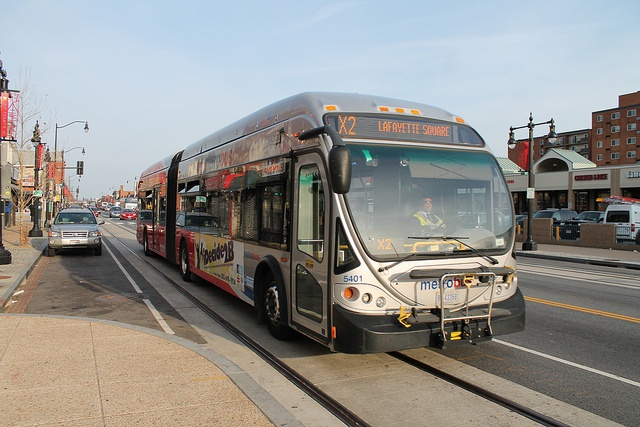Describe the objects in this image and their specific colors. I can see bus in lightblue, black, gray, darkgray, and ivory tones, car in lightblue, darkgray, black, gray, and lightgray tones, car in lightblue, black, darkgray, gray, and lightgray tones, people in lightblue, darkgray, khaki, tan, and beige tones, and car in lightblue, black, gray, and blue tones in this image. 